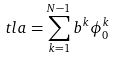<formula> <loc_0><loc_0><loc_500><loc_500>\ t l a = \sum _ { k = 1 } ^ { N - 1 } b ^ { k } \phi _ { 0 } ^ { k }</formula> 